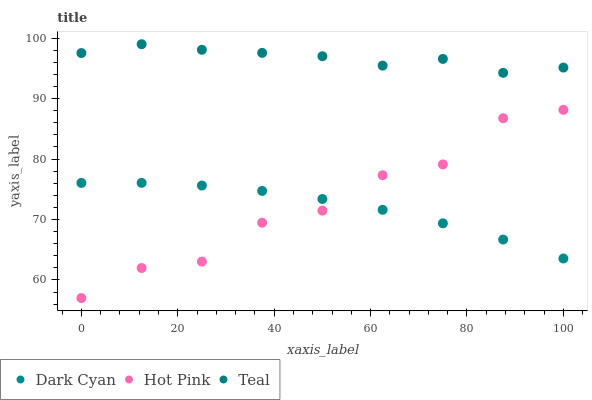Does Dark Cyan have the minimum area under the curve?
Answer yes or no. Yes. Does Teal have the maximum area under the curve?
Answer yes or no. Yes. Does Hot Pink have the minimum area under the curve?
Answer yes or no. No. Does Hot Pink have the maximum area under the curve?
Answer yes or no. No. Is Dark Cyan the smoothest?
Answer yes or no. Yes. Is Hot Pink the roughest?
Answer yes or no. Yes. Is Teal the smoothest?
Answer yes or no. No. Is Teal the roughest?
Answer yes or no. No. Does Hot Pink have the lowest value?
Answer yes or no. Yes. Does Teal have the lowest value?
Answer yes or no. No. Does Teal have the highest value?
Answer yes or no. Yes. Does Hot Pink have the highest value?
Answer yes or no. No. Is Dark Cyan less than Teal?
Answer yes or no. Yes. Is Teal greater than Dark Cyan?
Answer yes or no. Yes. Does Hot Pink intersect Dark Cyan?
Answer yes or no. Yes. Is Hot Pink less than Dark Cyan?
Answer yes or no. No. Is Hot Pink greater than Dark Cyan?
Answer yes or no. No. Does Dark Cyan intersect Teal?
Answer yes or no. No. 